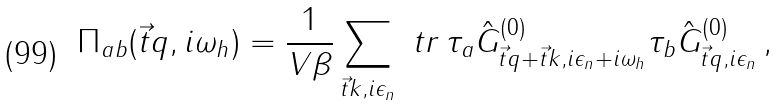<formula> <loc_0><loc_0><loc_500><loc_500>\Pi _ { a b } ( \vec { t } { q } , i \omega _ { h } ) = \frac { 1 } { V \beta } \sum _ { \vec { t } { k } , i \epsilon _ { n } } \ t r \, \tau _ { a } \hat { G } _ { \vec { t } { q } + \vec { t } { k } , i \epsilon _ { n } + i \omega _ { h } } ^ { ( 0 ) } \tau _ { b } \hat { G } _ { \vec { t } { q } , i \epsilon _ { n } } ^ { ( 0 ) } \, ,</formula> 